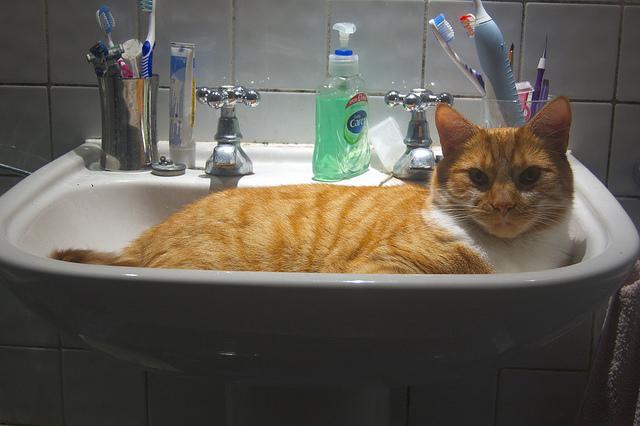Is the cat in its bed?
Concise answer only. No. Which animal is this?
Give a very brief answer. Cat. Where is the at laying?
Give a very brief answer. Sink. 